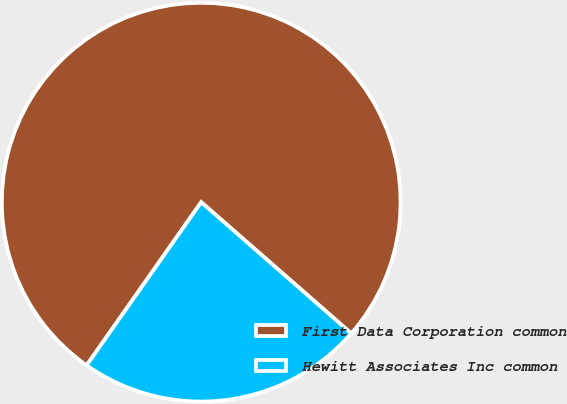<chart> <loc_0><loc_0><loc_500><loc_500><pie_chart><fcel>First Data Corporation common<fcel>Hewitt Associates Inc common<nl><fcel>76.69%<fcel>23.31%<nl></chart> 